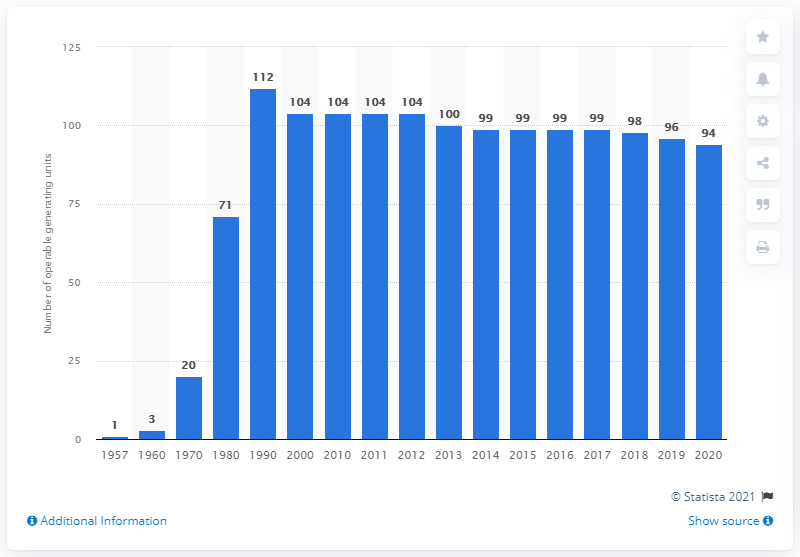Outline some significant characteristics in this image. In 2019, there were 94 generating units in the United States. 